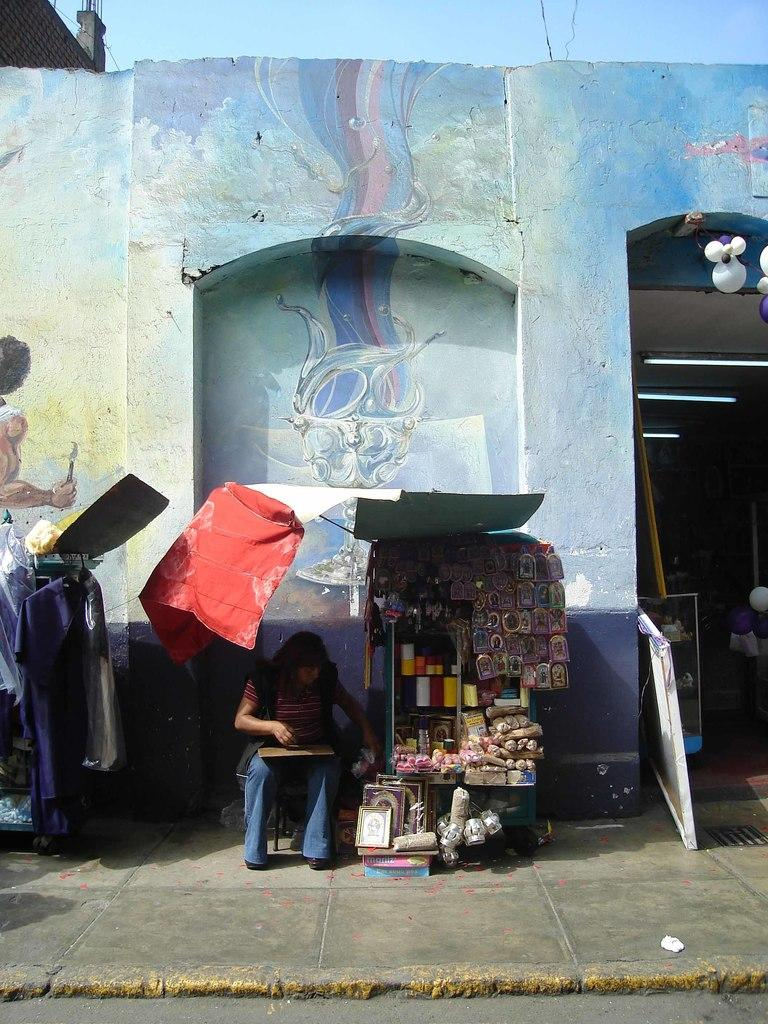What is the woman in the image doing? The woman is sitting in the image. Where is the woman sitting in relation to the wall? The woman is sitting in front of a wall. What is located beside the woman? There is a small store beside the woman. Can you describe the entrance in the image? The entrance is on the right side of the image, and the sky is visible above it. What type of knowledge does the donkey possess in the image? There is no donkey present in the image, so it is not possible to determine the knowledge it might possess. 